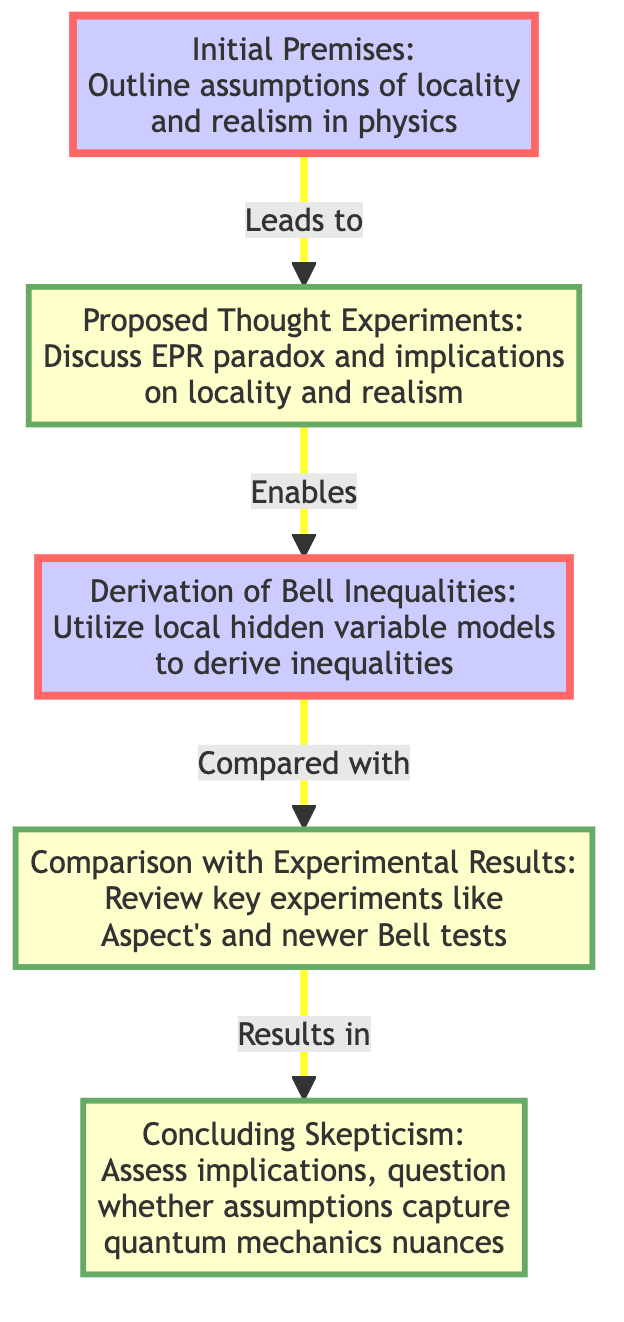What is the initial premise outlined in the diagram? The diagram specifies the "Initial Premises" node which includes assumptions of locality and realism in physics. This is clearly stated as the first node in the flowchart.
Answer: Initial Premises: Outline assumptions of locality and realism in physics Which node follows the “Proposed Thought Experiments” node? The flowchart shows a direct connection from the "Proposed Thought Experiments" node to the "Derivation of Bell Inequalities" node. This means that the thought experiments lead to the derivation of inequalities.
Answer: Derivation of Bell Inequalities How many nodes are present in the diagram? Counting all the distinct elements in the diagram - Initial Premises, Proposed Thought Experiments, Derivation of Bell Inequalities, Comparison with Experimental Results, and Concluding Skepticism yields a total of five nodes.
Answer: 5 What is the relationship between "Derivation of Bell Inequalities" and "Comparison with Experimental Results"? The connection between these two nodes is defined as "Compared with," indicating that the derived inequalities are analyzed in relation to experimental results. This relationship shows the flow of reasoning in the diagram.
Answer: Compared with What leads to the "Comparison with Experimental Results"? The diagram indicates that the "Derivation of Bell Inequalities" leads to the "Comparison with Experimental Results" node. Hence, deriving the inequalities is essential for comparing those with actual experimental outcomes.
Answer: Derivation of Bell Inequalities What final assessment is made in the "Concluding Skepticism" node? The final node discusses assessing the implications of the derived inequalities against the actual experimental results and questions if the initial assumptions accurately reflect the complexities of quantum mechanics.
Answer: Assess the implications of the derived inequalities vs actual experimental results What type of flow is used in the diagram? The diagram is structured as a flowchart with the flow moving from bottom to top, illustrating a sequential understanding and progression of thought in the analysis of Bell's Theorem.
Answer: Bottom to up Which color class is assigned to the "Initial Premises" and "Derivation of Bell Inequalities"? The "Initial Premises" and "Derivation of Bell Inequalities" nodes are classified with a custom style (custom1), which is indicated by the fill color and stroke width properties shown in the code.
Answer: custom1 